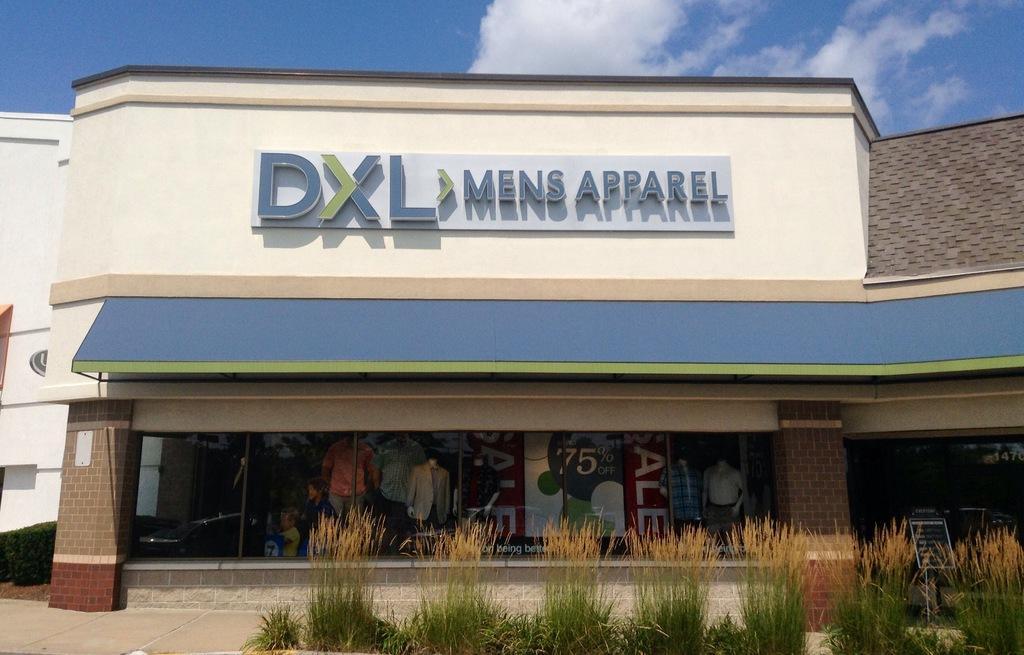Can you describe this image briefly? In this image we can see building, bushes, shrubs, plants, information boards, mannequins, advertisements, name boards and sky with clouds. 